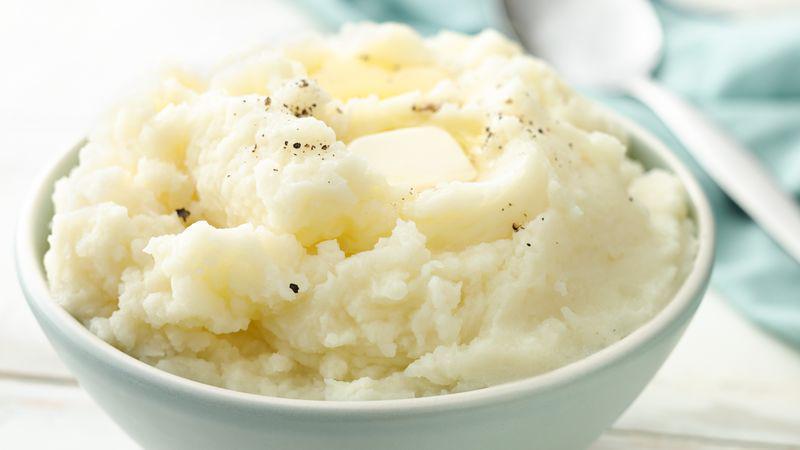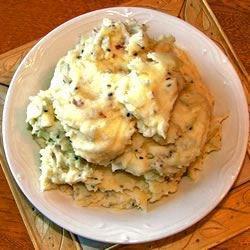The first image is the image on the left, the second image is the image on the right. For the images shown, is this caption "No bowl of potatoes has a utensil handle sticking out of it." true? Answer yes or no. Yes. The first image is the image on the left, the second image is the image on the right. Considering the images on both sides, is "There is a bowl of mashed potatoes with a spoon in it" valid? Answer yes or no. No. 